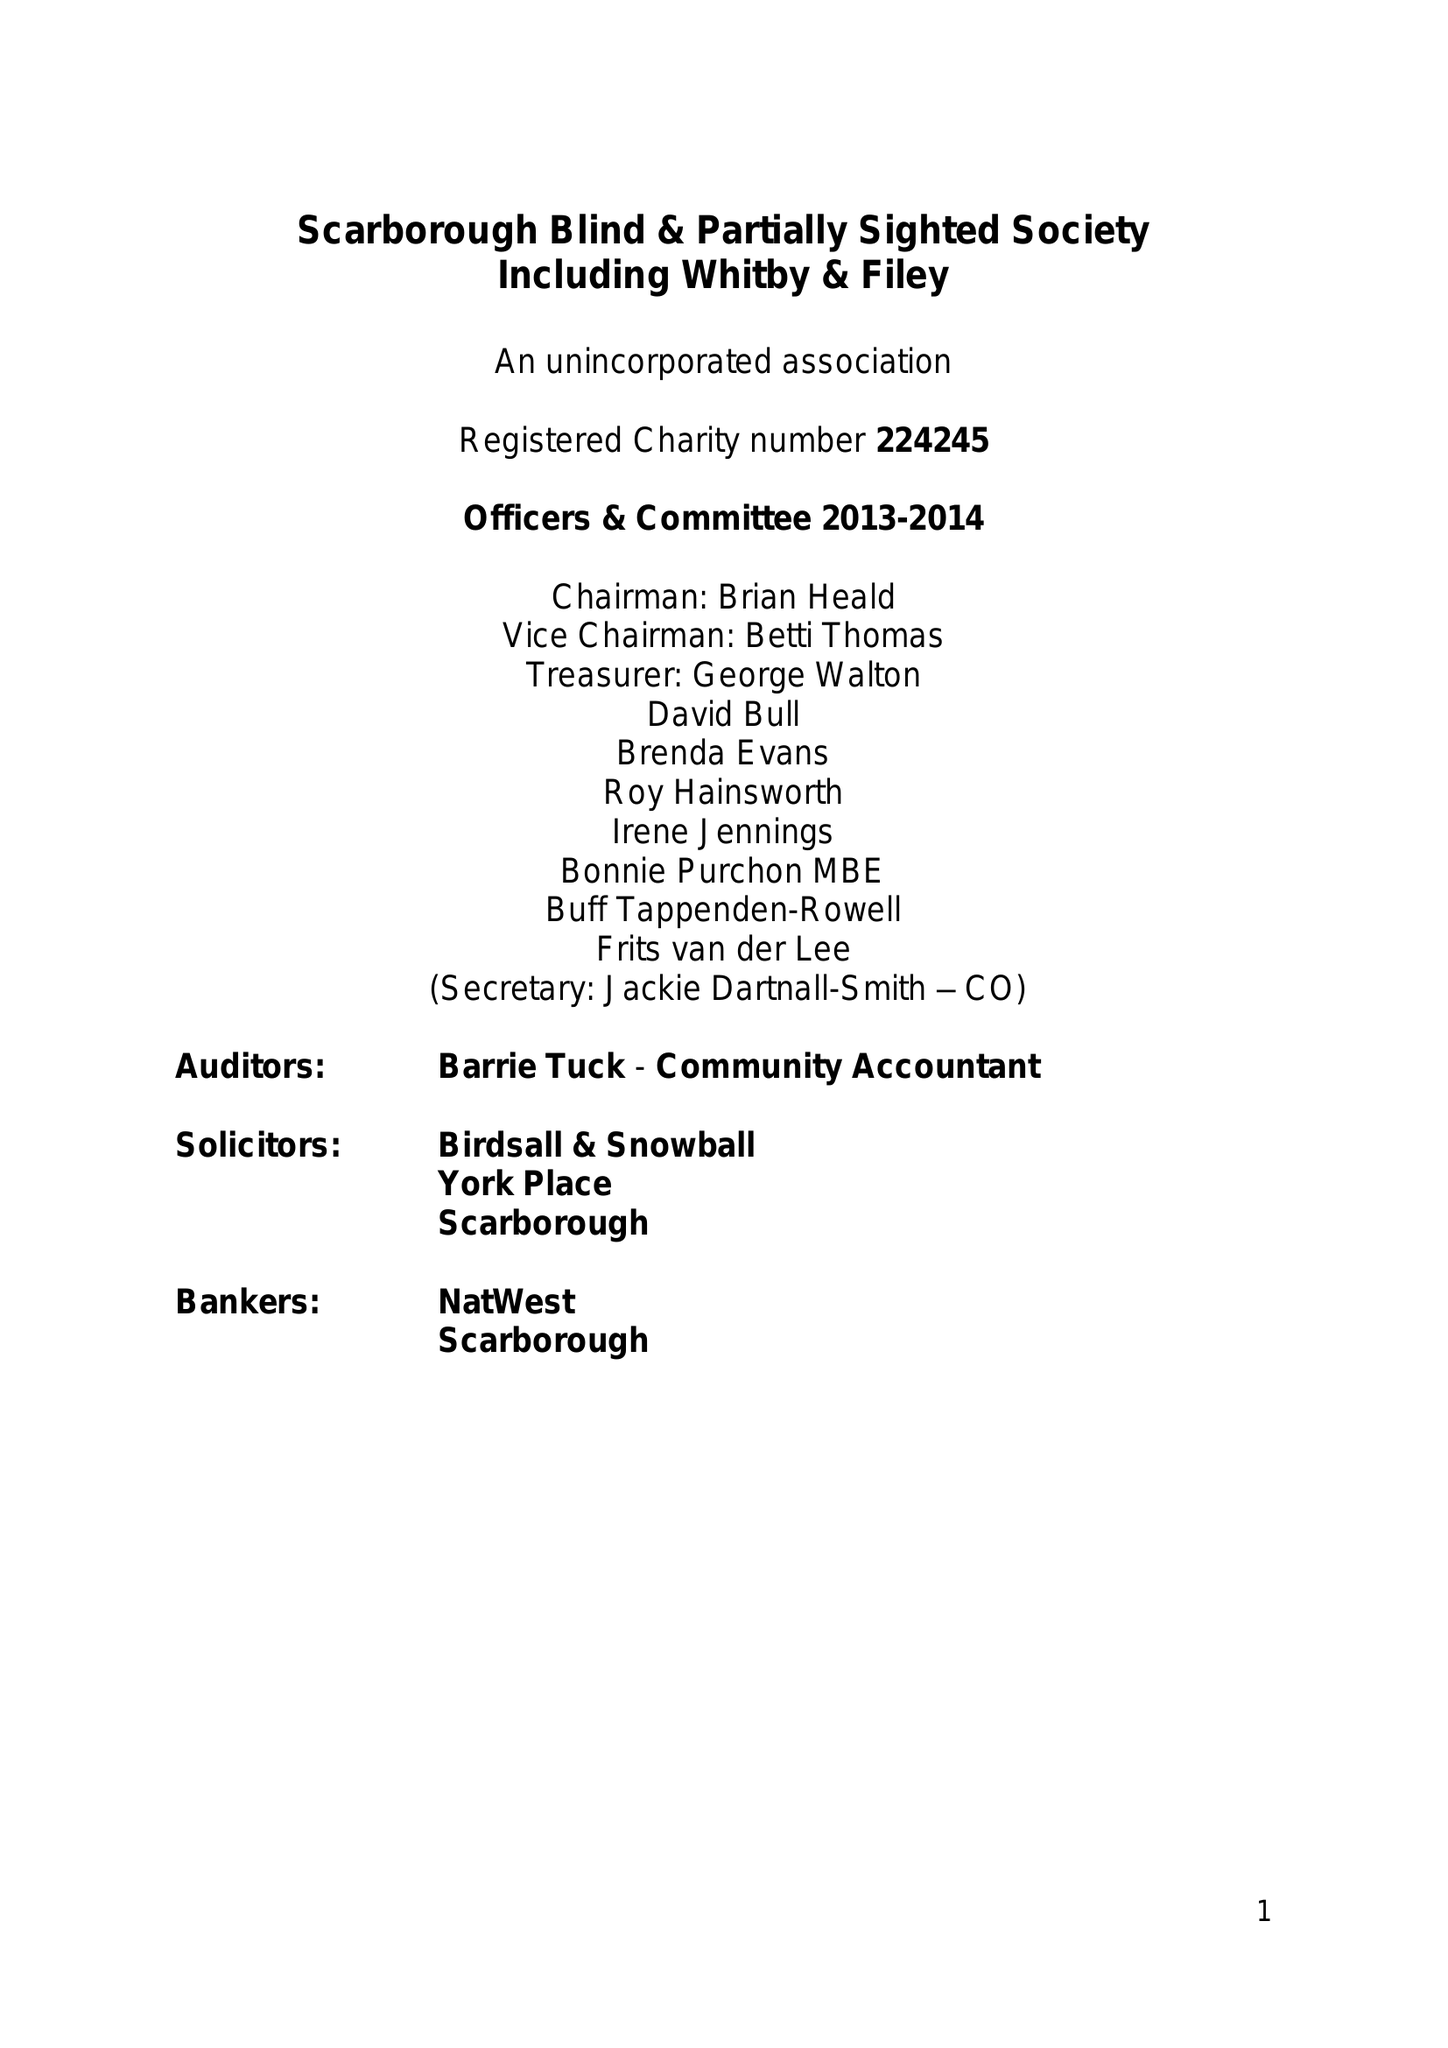What is the value for the address__street_line?
Answer the question using a single word or phrase. 181-183 DEAN ROAD 